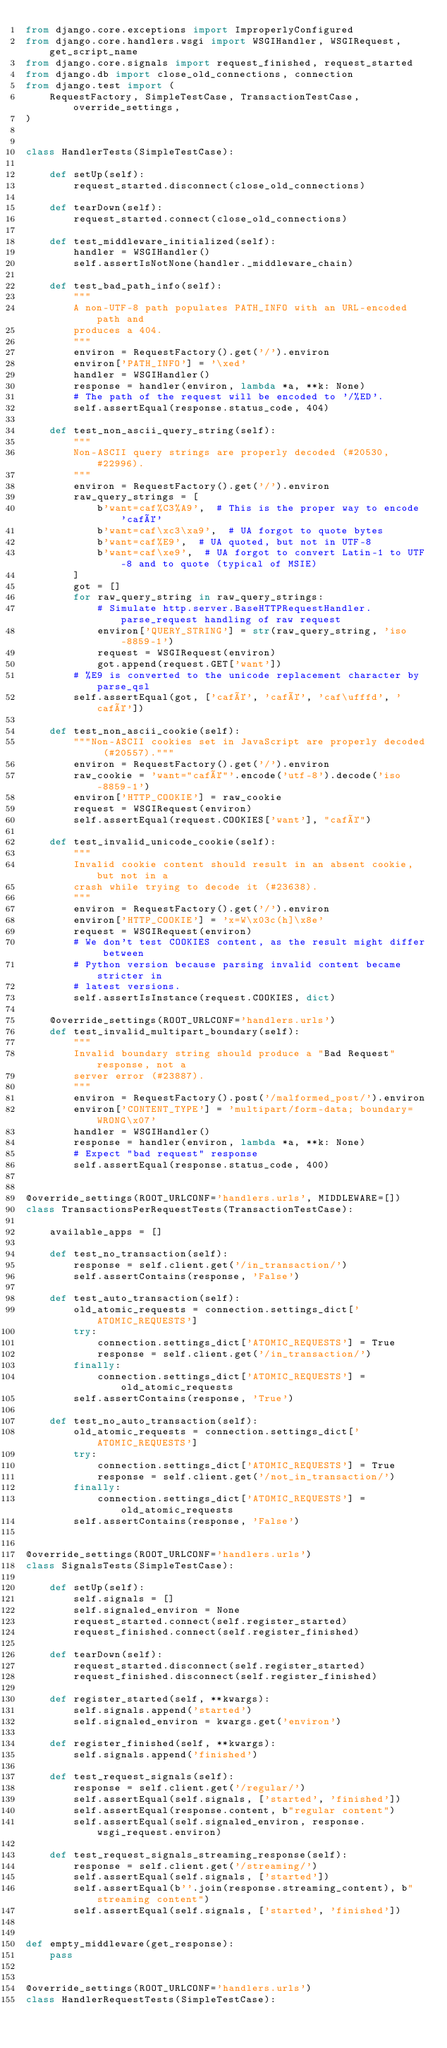Convert code to text. <code><loc_0><loc_0><loc_500><loc_500><_Python_>from django.core.exceptions import ImproperlyConfigured
from django.core.handlers.wsgi import WSGIHandler, WSGIRequest, get_script_name
from django.core.signals import request_finished, request_started
from django.db import close_old_connections, connection
from django.test import (
    RequestFactory, SimpleTestCase, TransactionTestCase, override_settings,
)


class HandlerTests(SimpleTestCase):

    def setUp(self):
        request_started.disconnect(close_old_connections)

    def tearDown(self):
        request_started.connect(close_old_connections)

    def test_middleware_initialized(self):
        handler = WSGIHandler()
        self.assertIsNotNone(handler._middleware_chain)

    def test_bad_path_info(self):
        """
        A non-UTF-8 path populates PATH_INFO with an URL-encoded path and
        produces a 404.
        """
        environ = RequestFactory().get('/').environ
        environ['PATH_INFO'] = '\xed'
        handler = WSGIHandler()
        response = handler(environ, lambda *a, **k: None)
        # The path of the request will be encoded to '/%ED'.
        self.assertEqual(response.status_code, 404)

    def test_non_ascii_query_string(self):
        """
        Non-ASCII query strings are properly decoded (#20530, #22996).
        """
        environ = RequestFactory().get('/').environ
        raw_query_strings = [
            b'want=caf%C3%A9',  # This is the proper way to encode 'café'
            b'want=caf\xc3\xa9',  # UA forgot to quote bytes
            b'want=caf%E9',  # UA quoted, but not in UTF-8
            b'want=caf\xe9',  # UA forgot to convert Latin-1 to UTF-8 and to quote (typical of MSIE)
        ]
        got = []
        for raw_query_string in raw_query_strings:
            # Simulate http.server.BaseHTTPRequestHandler.parse_request handling of raw request
            environ['QUERY_STRING'] = str(raw_query_string, 'iso-8859-1')
            request = WSGIRequest(environ)
            got.append(request.GET['want'])
        # %E9 is converted to the unicode replacement character by parse_qsl
        self.assertEqual(got, ['café', 'café', 'caf\ufffd', 'café'])

    def test_non_ascii_cookie(self):
        """Non-ASCII cookies set in JavaScript are properly decoded (#20557)."""
        environ = RequestFactory().get('/').environ
        raw_cookie = 'want="café"'.encode('utf-8').decode('iso-8859-1')
        environ['HTTP_COOKIE'] = raw_cookie
        request = WSGIRequest(environ)
        self.assertEqual(request.COOKIES['want'], "café")

    def test_invalid_unicode_cookie(self):
        """
        Invalid cookie content should result in an absent cookie, but not in a
        crash while trying to decode it (#23638).
        """
        environ = RequestFactory().get('/').environ
        environ['HTTP_COOKIE'] = 'x=W\x03c(h]\x8e'
        request = WSGIRequest(environ)
        # We don't test COOKIES content, as the result might differ between
        # Python version because parsing invalid content became stricter in
        # latest versions.
        self.assertIsInstance(request.COOKIES, dict)

    @override_settings(ROOT_URLCONF='handlers.urls')
    def test_invalid_multipart_boundary(self):
        """
        Invalid boundary string should produce a "Bad Request" response, not a
        server error (#23887).
        """
        environ = RequestFactory().post('/malformed_post/').environ
        environ['CONTENT_TYPE'] = 'multipart/form-data; boundary=WRONG\x07'
        handler = WSGIHandler()
        response = handler(environ, lambda *a, **k: None)
        # Expect "bad request" response
        self.assertEqual(response.status_code, 400)


@override_settings(ROOT_URLCONF='handlers.urls', MIDDLEWARE=[])
class TransactionsPerRequestTests(TransactionTestCase):

    available_apps = []

    def test_no_transaction(self):
        response = self.client.get('/in_transaction/')
        self.assertContains(response, 'False')

    def test_auto_transaction(self):
        old_atomic_requests = connection.settings_dict['ATOMIC_REQUESTS']
        try:
            connection.settings_dict['ATOMIC_REQUESTS'] = True
            response = self.client.get('/in_transaction/')
        finally:
            connection.settings_dict['ATOMIC_REQUESTS'] = old_atomic_requests
        self.assertContains(response, 'True')

    def test_no_auto_transaction(self):
        old_atomic_requests = connection.settings_dict['ATOMIC_REQUESTS']
        try:
            connection.settings_dict['ATOMIC_REQUESTS'] = True
            response = self.client.get('/not_in_transaction/')
        finally:
            connection.settings_dict['ATOMIC_REQUESTS'] = old_atomic_requests
        self.assertContains(response, 'False')


@override_settings(ROOT_URLCONF='handlers.urls')
class SignalsTests(SimpleTestCase):

    def setUp(self):
        self.signals = []
        self.signaled_environ = None
        request_started.connect(self.register_started)
        request_finished.connect(self.register_finished)

    def tearDown(self):
        request_started.disconnect(self.register_started)
        request_finished.disconnect(self.register_finished)

    def register_started(self, **kwargs):
        self.signals.append('started')
        self.signaled_environ = kwargs.get('environ')

    def register_finished(self, **kwargs):
        self.signals.append('finished')

    def test_request_signals(self):
        response = self.client.get('/regular/')
        self.assertEqual(self.signals, ['started', 'finished'])
        self.assertEqual(response.content, b"regular content")
        self.assertEqual(self.signaled_environ, response.wsgi_request.environ)

    def test_request_signals_streaming_response(self):
        response = self.client.get('/streaming/')
        self.assertEqual(self.signals, ['started'])
        self.assertEqual(b''.join(response.streaming_content), b"streaming content")
        self.assertEqual(self.signals, ['started', 'finished'])


def empty_middleware(get_response):
    pass


@override_settings(ROOT_URLCONF='handlers.urls')
class HandlerRequestTests(SimpleTestCase):
</code> 